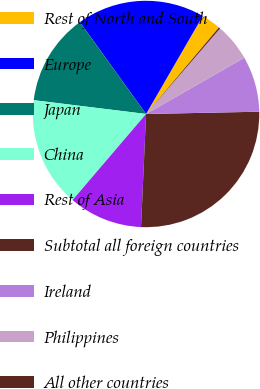Convert chart to OTSL. <chart><loc_0><loc_0><loc_500><loc_500><pie_chart><fcel>Rest of North and South<fcel>Europe<fcel>Japan<fcel>China<fcel>Rest of Asia<fcel>Subtotal all foreign countries<fcel>Ireland<fcel>Philippines<fcel>All other countries<nl><fcel>2.79%<fcel>18.28%<fcel>13.12%<fcel>15.7%<fcel>10.54%<fcel>26.03%<fcel>7.96%<fcel>5.37%<fcel>0.21%<nl></chart> 